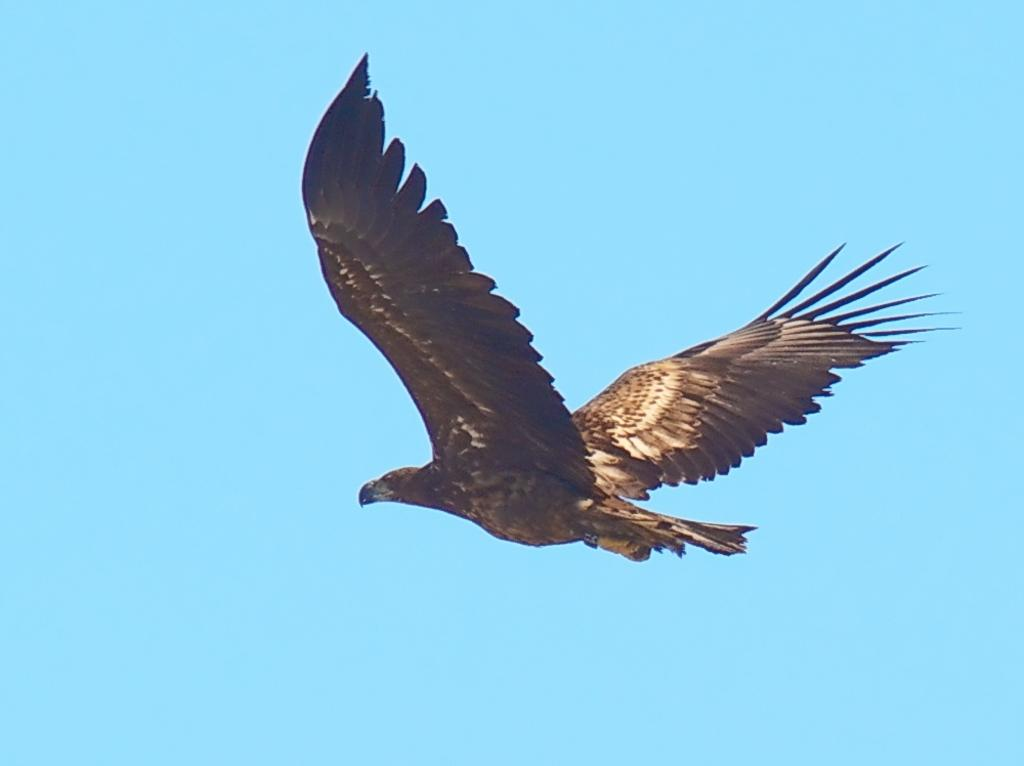What is the main subject of the image? The main subject of the image is a bird flying. What can be seen in the background of the image? The sky is visible in the background of the image. What type of transport is being used by the bird in the image? The bird is flying, so it does not require any form of transport. Is there any mention of a tax in the image? There is no mention of a tax in the image; it features a bird flying in the sky. 